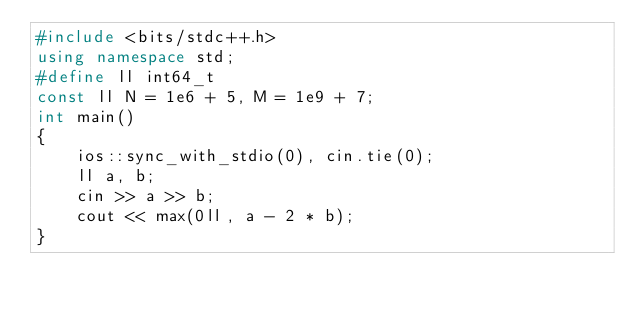Convert code to text. <code><loc_0><loc_0><loc_500><loc_500><_C++_>#include <bits/stdc++.h>
using namespace std;
#define ll int64_t
const ll N = 1e6 + 5, M = 1e9 + 7;
int main()
{
    ios::sync_with_stdio(0), cin.tie(0);
    ll a, b;
    cin >> a >> b;
    cout << max(0ll, a - 2 * b);
}</code> 